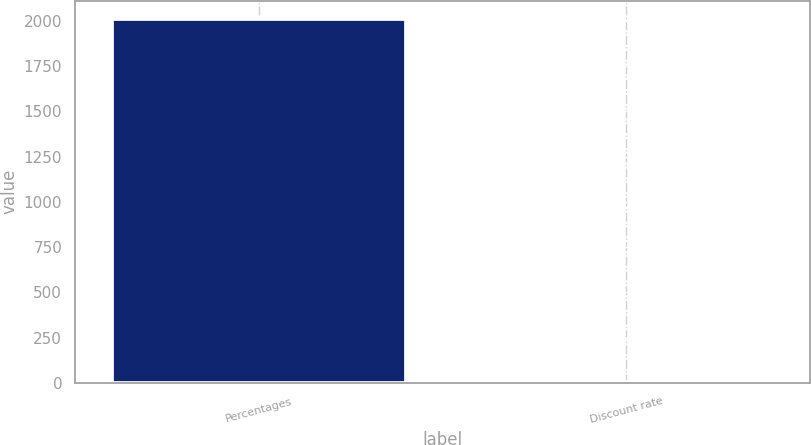Convert chart. <chart><loc_0><loc_0><loc_500><loc_500><bar_chart><fcel>Percentages<fcel>Discount rate<nl><fcel>2012<fcel>4.54<nl></chart> 